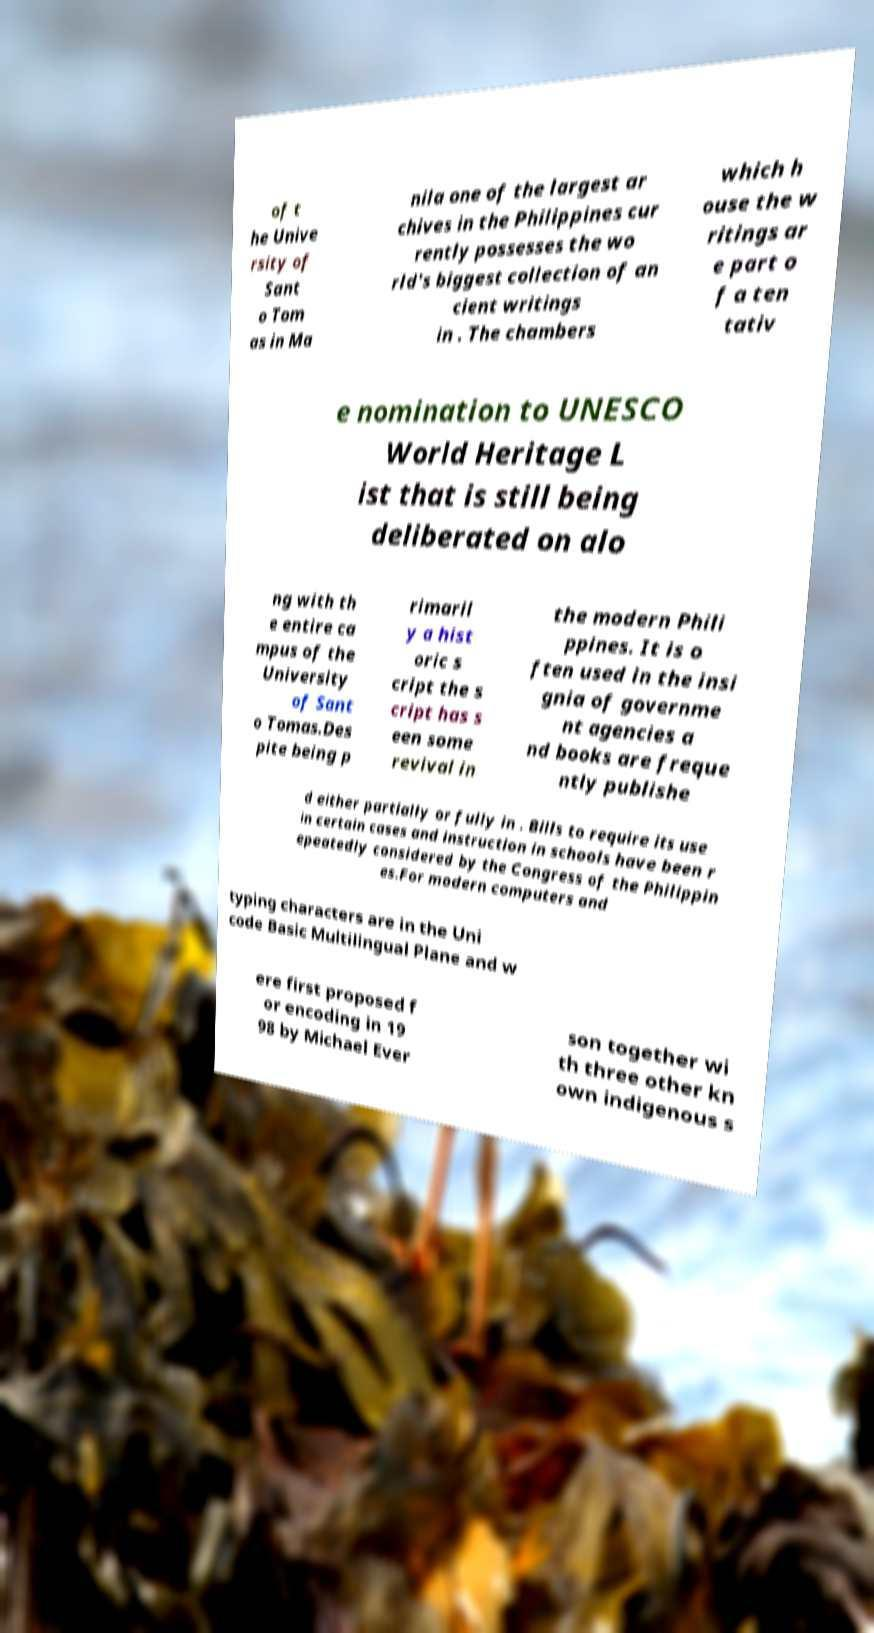Can you read and provide the text displayed in the image?This photo seems to have some interesting text. Can you extract and type it out for me? of t he Unive rsity of Sant o Tom as in Ma nila one of the largest ar chives in the Philippines cur rently possesses the wo rld's biggest collection of an cient writings in . The chambers which h ouse the w ritings ar e part o f a ten tativ e nomination to UNESCO World Heritage L ist that is still being deliberated on alo ng with th e entire ca mpus of the University of Sant o Tomas.Des pite being p rimaril y a hist oric s cript the s cript has s een some revival in the modern Phili ppines. It is o ften used in the insi gnia of governme nt agencies a nd books are freque ntly publishe d either partially or fully in . Bills to require its use in certain cases and instruction in schools have been r epeatedly considered by the Congress of the Philippin es.For modern computers and typing characters are in the Uni code Basic Multilingual Plane and w ere first proposed f or encoding in 19 98 by Michael Ever son together wi th three other kn own indigenous s 